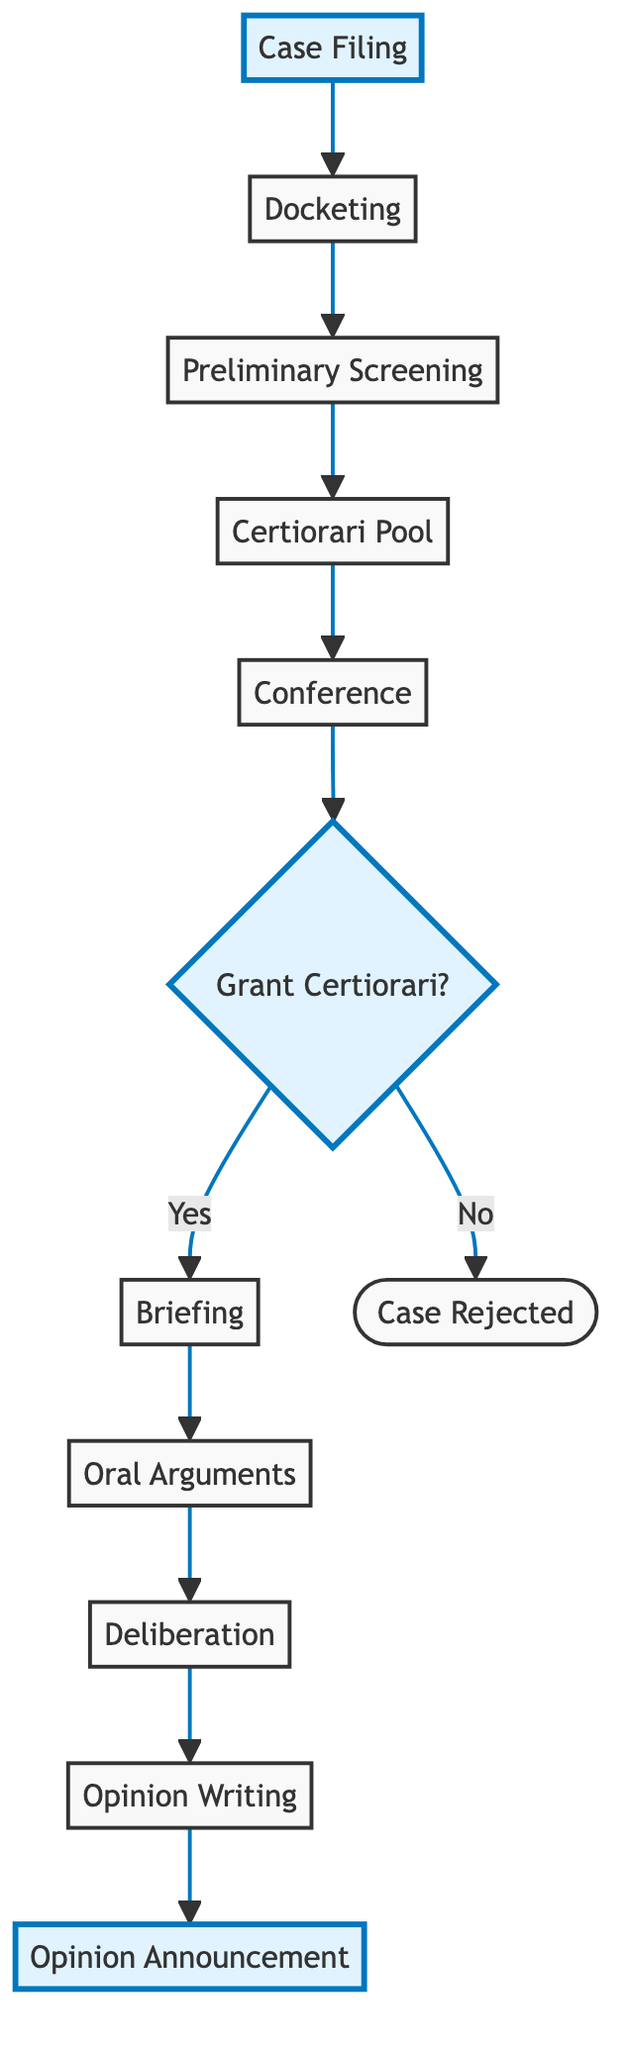What is the first step in the Judicial Decision Process Flow? The flowchart starts with "Case Filing" as the initial step where litigants file a petition for review.
Answer: Case Filing How many steps are there in the process? The diagram includes 11 distinct steps, counting each sequential action from the initial case filing to the final opinion announcement.
Answer: 11 What happens after "Preliminary Screening"? After the "Preliminary Screening," the next step in the flow is "Certiorari Pool," where justices' clerks summarize petitions and recommend further actions.
Answer: Certiorari Pool What decision is made during the "Conference"? In the "Conference" step, justices discuss the cases and vote on whether to accept the cases for review.
Answer: Vote What is the outcome if "Grant Certiorari" is No? If the decision at "Grant Certiorari" is no, the flow shows that the case is "Rejected," which means it will not be heard by the Supreme Court.
Answer: Case Rejected How is the "Opinion Writing" step connected to the previous step? "Opinion Writing" follows "Deliberation," as the justices meet to discuss their conclusions before one justice is assigned to write the Court's opinion.
Answer: After Deliberation What type of briefs are submitted during "Briefing"? During "Briefing," both parties submit written briefs, and additional amicus curiae briefs can also be filed to provide supplementary perspectives.
Answer: Written and amicus curiae briefs What is the final step in the Judicial Decision Process Flow? The final step is "Opinion Announcement," where the Court's decision and rationale are publicly announced and published.
Answer: Opinion Announcement Who must vote in favor for a case to be accepted in "Granting Certiorari"? For the Court to agree to hear a case in "Granting Certiorari," at least four justices must vote in favor of the petition.
Answer: Four justices 